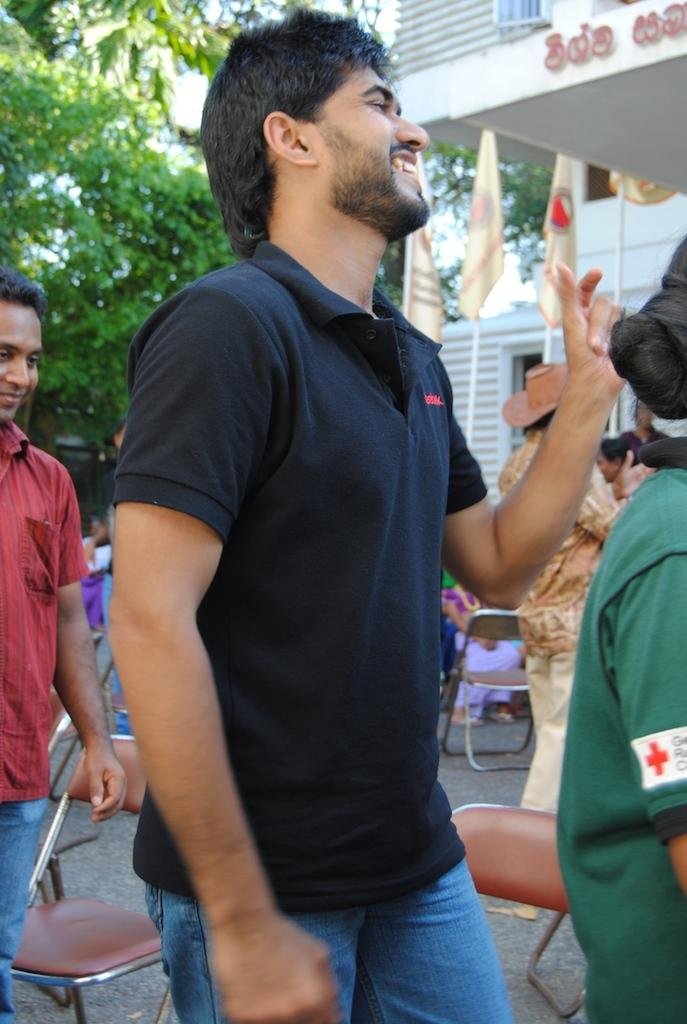Who or what can be seen in the image? There are people in the image. What are the people sitting on in the image? There are chairs in the image. What decorative or symbolic items are present in the image? There are flags in the image. What type of building is visible in the image? There is a house in the image. What type of plant or vegetation is present in the image? There is a tree in the image. Can you see any jellyfish swimming in the image? There are no jellyfish present in the image. What type of window can be seen in the image? There is no window mentioned or visible in the image. 